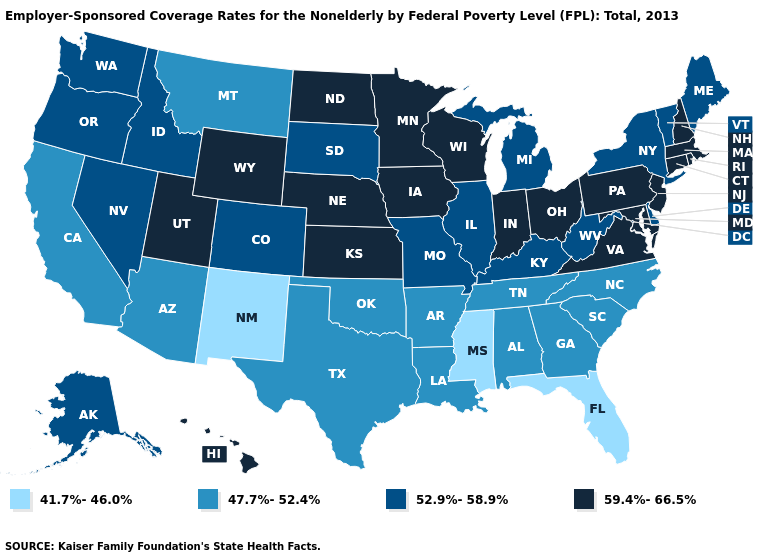Name the states that have a value in the range 59.4%-66.5%?
Quick response, please. Connecticut, Hawaii, Indiana, Iowa, Kansas, Maryland, Massachusetts, Minnesota, Nebraska, New Hampshire, New Jersey, North Dakota, Ohio, Pennsylvania, Rhode Island, Utah, Virginia, Wisconsin, Wyoming. Name the states that have a value in the range 59.4%-66.5%?
Write a very short answer. Connecticut, Hawaii, Indiana, Iowa, Kansas, Maryland, Massachusetts, Minnesota, Nebraska, New Hampshire, New Jersey, North Dakota, Ohio, Pennsylvania, Rhode Island, Utah, Virginia, Wisconsin, Wyoming. What is the highest value in the South ?
Quick response, please. 59.4%-66.5%. What is the value of Michigan?
Be succinct. 52.9%-58.9%. Name the states that have a value in the range 41.7%-46.0%?
Answer briefly. Florida, Mississippi, New Mexico. What is the value of Indiana?
Answer briefly. 59.4%-66.5%. What is the value of Oregon?
Write a very short answer. 52.9%-58.9%. What is the lowest value in the South?
Write a very short answer. 41.7%-46.0%. Does Vermont have the lowest value in the Northeast?
Short answer required. Yes. What is the highest value in states that border New Mexico?
Concise answer only. 59.4%-66.5%. Does Maine have a higher value than Louisiana?
Be succinct. Yes. What is the value of Nevada?
Quick response, please. 52.9%-58.9%. What is the value of Alabama?
Short answer required. 47.7%-52.4%. What is the lowest value in the USA?
Be succinct. 41.7%-46.0%. Is the legend a continuous bar?
Concise answer only. No. 